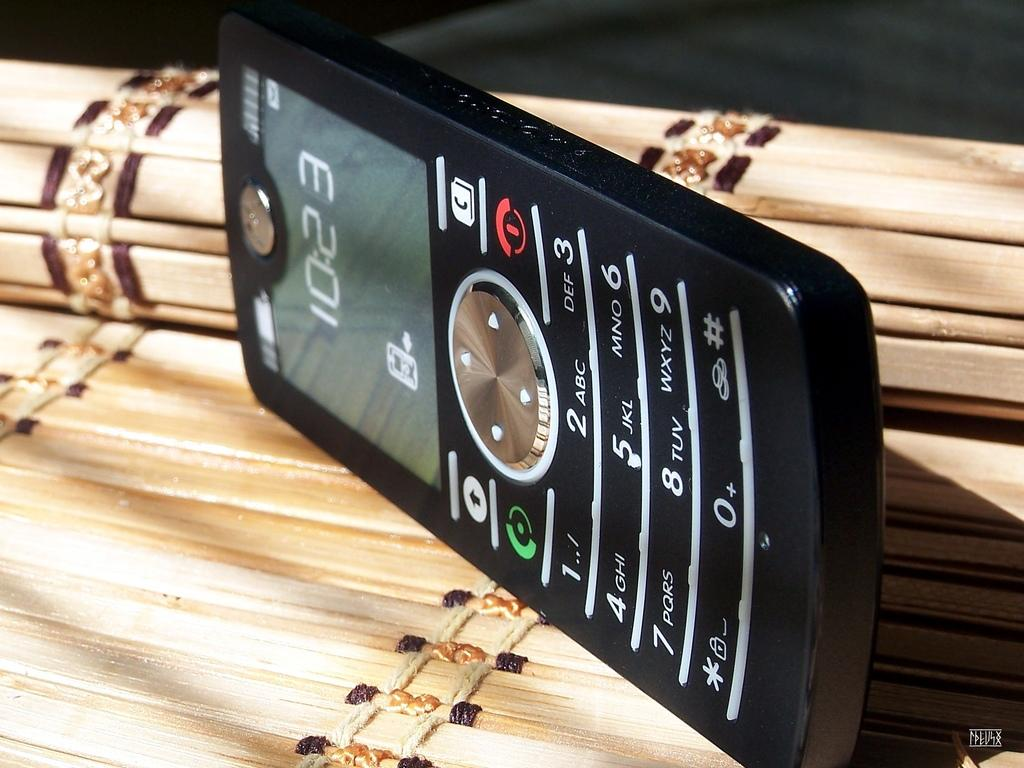<image>
Render a clear and concise summary of the photo. Phone on it's side with the time 10:23 on the screen. 